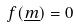<formula> <loc_0><loc_0><loc_500><loc_500>f ( \underline { m } ) = 0</formula> 